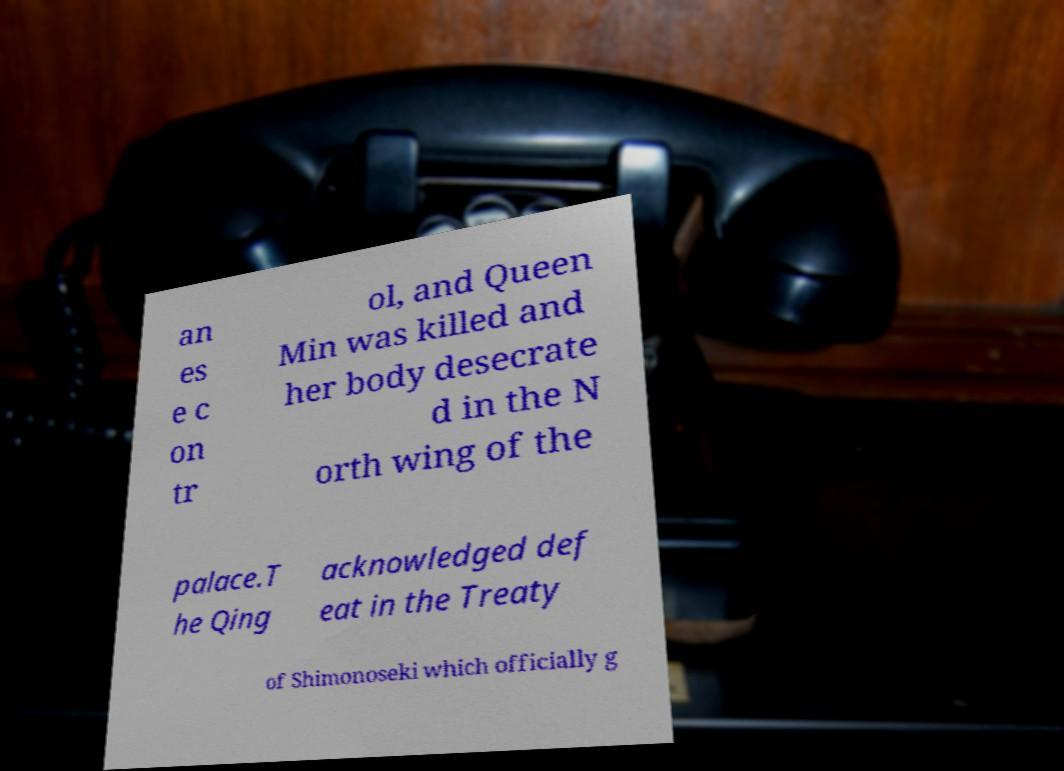Could you assist in decoding the text presented in this image and type it out clearly? an es e c on tr ol, and Queen Min was killed and her body desecrate d in the N orth wing of the palace.T he Qing acknowledged def eat in the Treaty of Shimonoseki which officially g 